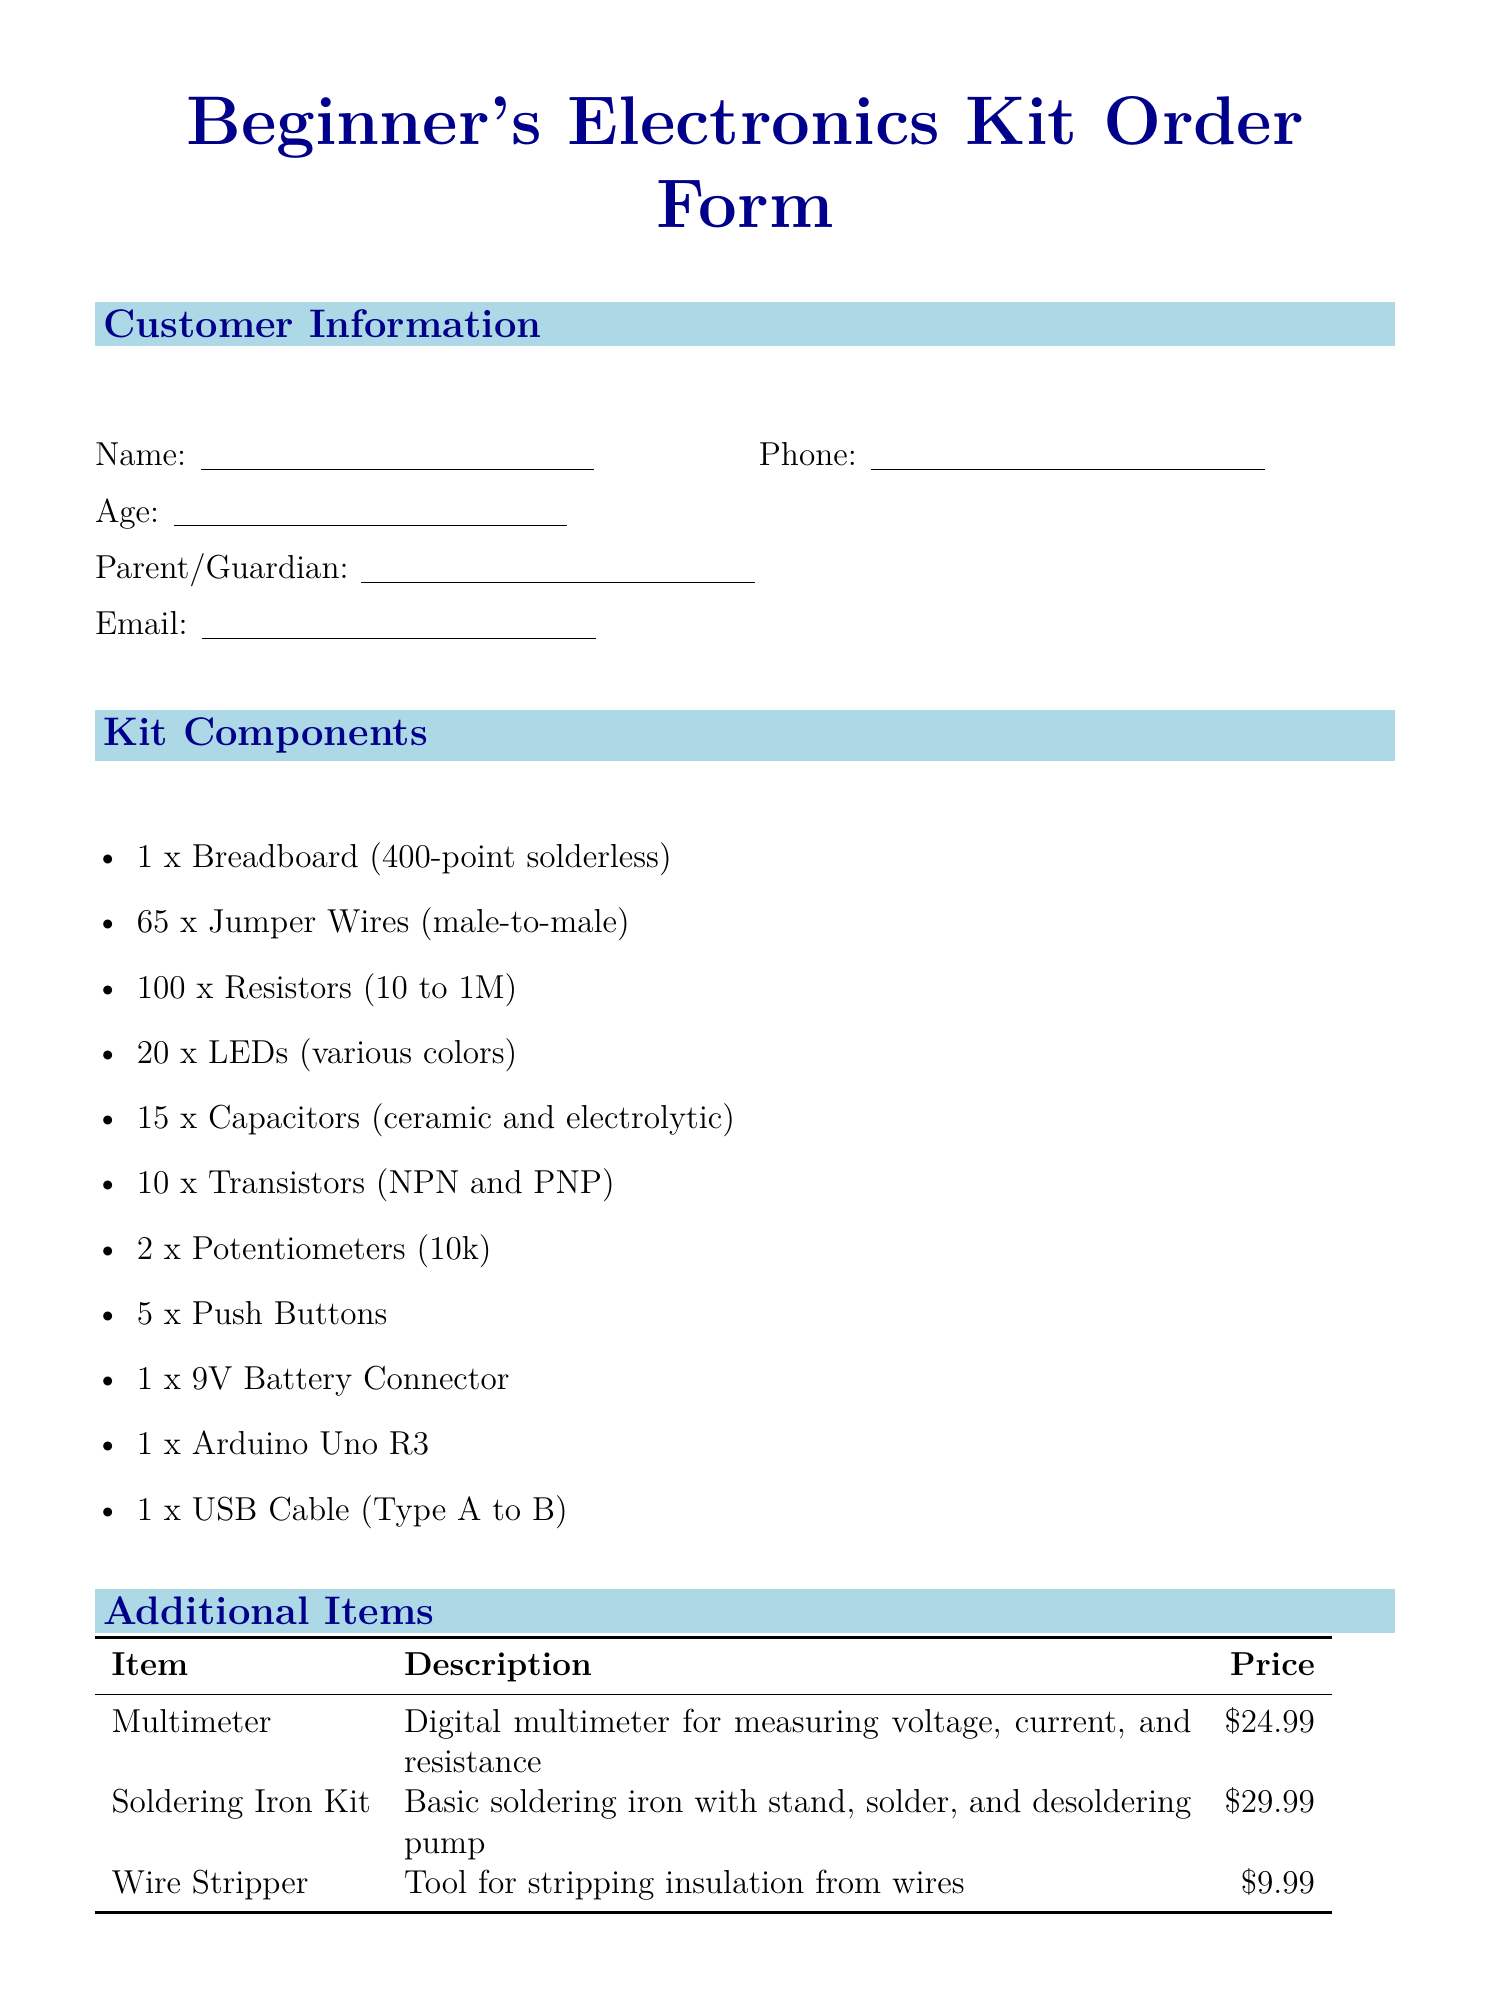What is the title of the order form? The title of the order form is listed at the top of the document.
Answer: Beginner's Electronics Kit Order Form How many Jumper Wires are included in the kit? The quantity of Jumper Wires is specified in the kit components section.
Answer: 65 What is the price of the Soldering Iron Kit? The price can be found in the additional items table.
Answer: 29.99 What is the estimated delivery time for Express Shipping? The estimated delivery time for each shipping option is provided in the shipping options section.
Answer: 2-3 business days How many components are listed in the Kit Components section? The total number of components can be counted from the list provided.
Answer: 11 What is the description of the Multimeter? The description is found in the additional items section of the document.
Answer: Digital multimeter for measuring voltage, current, and resistance Which shipping method has a lower price? The shipping methods and their prices are presented side by side for comparison.
Answer: Standard Shipping What are the terms regarding returns? The terms and conditions state details about returns clearly.
Answer: Returns accepted within 30 days of purchase if unopened and in original condition 